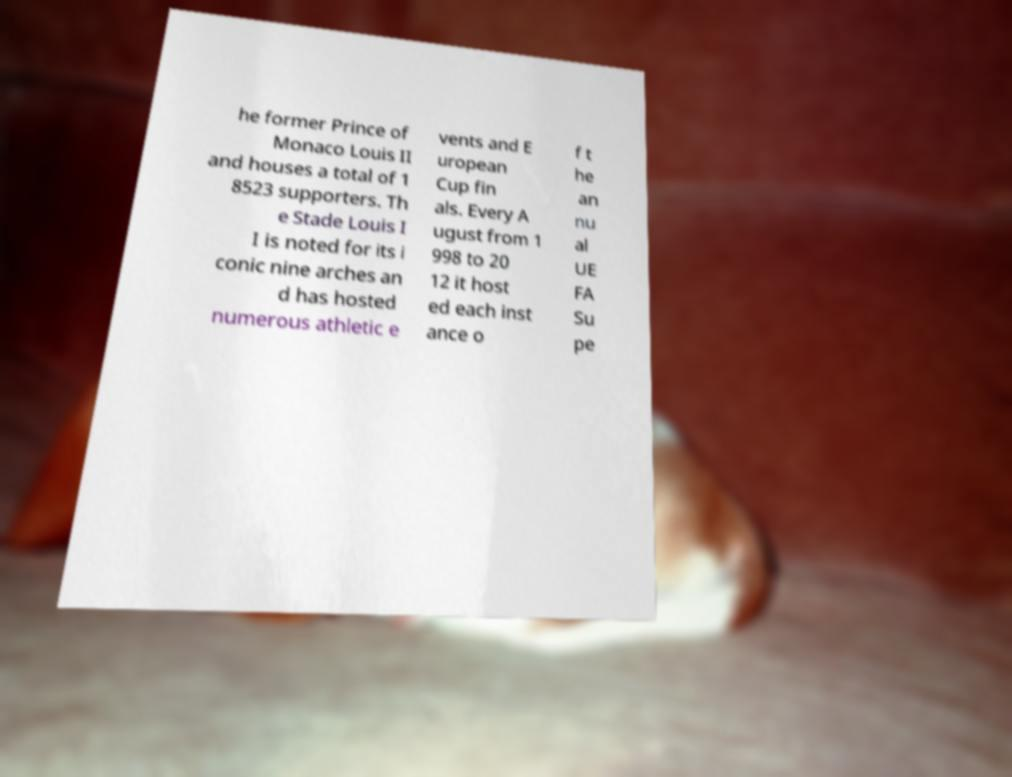For documentation purposes, I need the text within this image transcribed. Could you provide that? he former Prince of Monaco Louis II and houses a total of 1 8523 supporters. Th e Stade Louis I I is noted for its i conic nine arches an d has hosted numerous athletic e vents and E uropean Cup fin als. Every A ugust from 1 998 to 20 12 it host ed each inst ance o f t he an nu al UE FA Su pe 